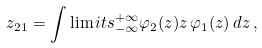Convert formula to latex. <formula><loc_0><loc_0><loc_500><loc_500>z _ { 2 1 } = \int \lim i t s _ { - \infty } ^ { + \infty } \varphi _ { 2 } ( z ) z \, \varphi _ { 1 } ( z ) \, d z \, ,</formula> 